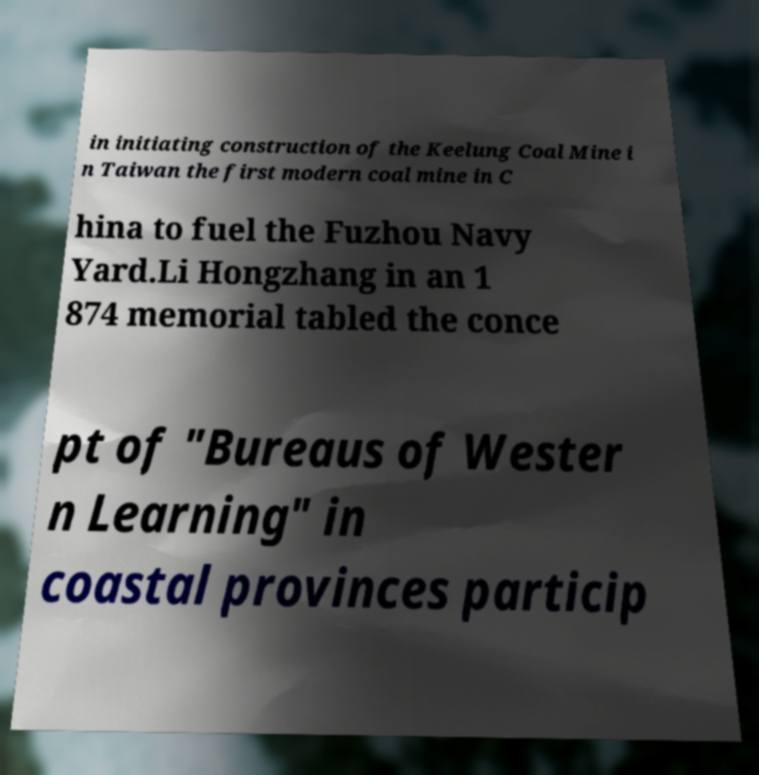There's text embedded in this image that I need extracted. Can you transcribe it verbatim? in initiating construction of the Keelung Coal Mine i n Taiwan the first modern coal mine in C hina to fuel the Fuzhou Navy Yard.Li Hongzhang in an 1 874 memorial tabled the conce pt of "Bureaus of Wester n Learning" in coastal provinces particip 